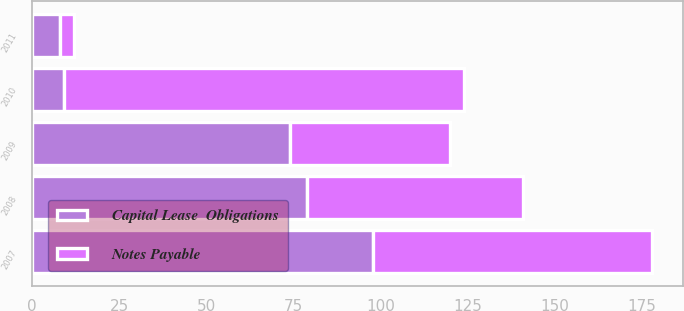Convert chart to OTSL. <chart><loc_0><loc_0><loc_500><loc_500><stacked_bar_chart><ecel><fcel>2007<fcel>2008<fcel>2009<fcel>2010<fcel>2011<nl><fcel>Notes Payable<fcel>80<fcel>62<fcel>46<fcel>115<fcel>4<nl><fcel>Capital Lease  Obligations<fcel>98<fcel>79<fcel>74<fcel>9<fcel>8<nl></chart> 